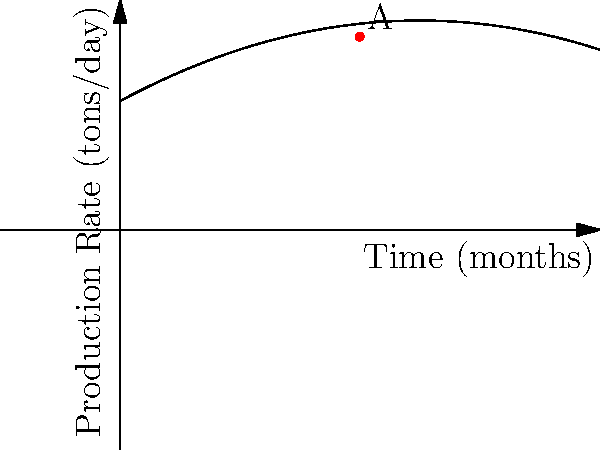The graph shows the production rate of synthetic fabrics over time in a textile factory. Point A represents the peak production rate. Using the coordinate system, determine the maximum production rate and the time at which it occurs. How might this peak and subsequent decline relate to potential health and safety concerns in synthetic fabric production? To solve this problem, we need to follow these steps:

1. Identify the coordinates of point A:
   From the graph, we can see that point A is at (10, 7.5).

2. Interpret the coordinates:
   - The x-coordinate (10) represents the time in months.
   - The y-coordinate (7.5) represents the production rate in tons per day.

3. Analyze the graph:
   The curve increases to a peak at point A and then decreases, forming a parabola.

4. Relate to health and safety concerns:
   The peak and subsequent decline in production rate could indicate:
   - Increased worker fatigue or health issues due to high production demands.
   - Potential equipment wear leading to safety risks.
   - Possible buildup of harmful chemicals or byproducts over time.

5. Mathematical representation:
   The production rate function appears to be a quadratic equation in the form:
   $$f(x) = -ax^2 + bx + c$$
   where $x$ is time in months and $f(x)$ is production rate in tons per day.

6. Health and safety implications:
   - The decline after the peak might necessitate a review of production processes.
   - It could indicate a need for improved ventilation or protective equipment.
   - The factory might need to consider implementing rotation schedules or additional breaks for workers.
Answer: Maximum production rate: 7.5 tons/day at 10 months. The peak and decline may indicate increased health and safety risks due to worker fatigue, equipment wear, or chemical buildup. 